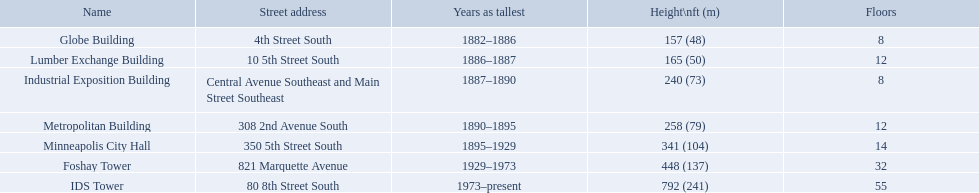What years was 240 ft considered tall? 1887–1890. What building held this record? Industrial Exposition Building. What are the tallest buildings in minneapolis? Globe Building, Lumber Exchange Building, Industrial Exposition Building, Metropolitan Building, Minneapolis City Hall, Foshay Tower, IDS Tower. Which of those have 8 floors? Globe Building, Industrial Exposition Building. Of those, which is 240 ft tall? Industrial Exposition Building. What are the tallest buildings in minneapolis? Globe Building, Lumber Exchange Building, Industrial Exposition Building, Metropolitan Building, Minneapolis City Hall, Foshay Tower, IDS Tower. What is the height of the metropolitan building? 258 (79). What is the height of the lumber exchange building? 165 (50). Of those two which is taller? Metropolitan Building. How tall is the metropolitan building? 258 (79). How tall is the lumber exchange building? 165 (50). Can you give me this table in json format? {'header': ['Name', 'Street address', 'Years as tallest', 'Height\\nft (m)', 'Floors'], 'rows': [['Globe Building', '4th Street South', '1882–1886', '157 (48)', '8'], ['Lumber Exchange Building', '10 5th Street South', '1886–1887', '165 (50)', '12'], ['Industrial Exposition Building', 'Central Avenue Southeast and Main Street Southeast', '1887–1890', '240 (73)', '8'], ['Metropolitan Building', '308 2nd Avenue South', '1890–1895', '258 (79)', '12'], ['Minneapolis City Hall', '350 5th Street South', '1895–1929', '341 (104)', '14'], ['Foshay Tower', '821 Marquette Avenue', '1929–1973', '448 (137)', '32'], ['IDS Tower', '80 8th Street South', '1973–present', '792 (241)', '55']]} Is the metropolitan or lumber exchange building taller? Metropolitan Building. Which buildings have the same number of floors as another building? Globe Building, Lumber Exchange Building, Industrial Exposition Building, Metropolitan Building. Of those, which has the same as the lumber exchange building? Metropolitan Building. How many floors does the lumber exchange building have? 12. What other building has 12 floors? Metropolitan Building. What are the loftiest edifices in minneapolis? Globe Building, Lumber Exchange Building, Industrial Exposition Building, Metropolitan Building, Minneapolis City Hall, Foshay Tower, IDS Tower. What is the elevation of the metropolitan building? 258 (79). What is the elevation of the lumber exchange building? 165 (50). Of those two, which is higher? Metropolitan Building. How high is the metropolitan building? 258 (79). How high is the lumber exchange building? 165 (50). Which building is higher, metropolitan or lumber exchange? Metropolitan Building. How many levels are there in the lumber exchange building? 12. What other edifice consists of 12 levels? Metropolitan Building. Which edifices have the identical quantity of levels as another edifice? Globe Building, Lumber Exchange Building, Industrial Exposition Building, Metropolitan Building. From those, which matches the lumber exchange building? Metropolitan Building. How many stories does the lumber exchange building possess? 12. What other structure has 12 stories? Metropolitan Building. What are the loftiest edifices in minneapolis? Globe Building, Lumber Exchange Building, Industrial Exposition Building, Metropolitan Building, Minneapolis City Hall, Foshay Tower, IDS Tower. Which of these have 8 levels? Globe Building, Industrial Exposition Building. Out of them, which one stands at 240 ft tall? Industrial Exposition Building. What is the height of each building? 157 (48), 165 (50), 240 (73), 258 (79), 341 (104), 448 (137), 792 (241). Please point out the building that stands 240 ft tall.? Industrial Exposition Building. Help me parse the entirety of this table. {'header': ['Name', 'Street address', 'Years as tallest', 'Height\\nft (m)', 'Floors'], 'rows': [['Globe Building', '4th Street South', '1882–1886', '157 (48)', '8'], ['Lumber Exchange Building', '10 5th Street South', '1886–1887', '165 (50)', '12'], ['Industrial Exposition Building', 'Central Avenue Southeast and Main Street Southeast', '1887–1890', '240 (73)', '8'], ['Metropolitan Building', '308 2nd Avenue South', '1890–1895', '258 (79)', '12'], ['Minneapolis City Hall', '350 5th Street South', '1895–1929', '341 (104)', '14'], ['Foshay Tower', '821 Marquette Avenue', '1929–1973', '448 (137)', '32'], ['IDS Tower', '80 8th Street South', '1973–present', '792 (241)', '55']]} During which years was 240 ft regarded as a significant height? 1887–1890. What building had this record? Industrial Exposition Building. When was a 240 ft height considered notable? 1887–1890. Which construction possessed this distinction? Industrial Exposition Building. What are the highest structures in minneapolis? Globe Building, Lumber Exchange Building, Industrial Exposition Building, Metropolitan Building, Minneapolis City Hall, Foshay Tower, IDS Tower. Is there any 8-story building among them? Globe Building, Industrial Exposition Building. Additionally, which one has a height of 240 feet? Industrial Exposition Building. What is the height of the metropolitan building? 258 (79). What is the height of the lumber exchange building? 165 (50). Which one is taller, the metropolitan or the lumber exchange building? Metropolitan Building. Which edifices have a matching number of floors with another edifice? Globe Building, Lumber Exchange Building, Industrial Exposition Building, Metropolitan Building. Among these, which one has the same number as the lumber exchange building? Metropolitan Building. How many levels are there in the globe building? 8. Can you identify the building with 14 floors? Minneapolis City Hall. Which building shares the same number of floors as the lumber exchange building? Metropolitan Building. What is the number of floors in the lumber exchange building? 12. Can you name another building with 12 floors? Metropolitan Building. 